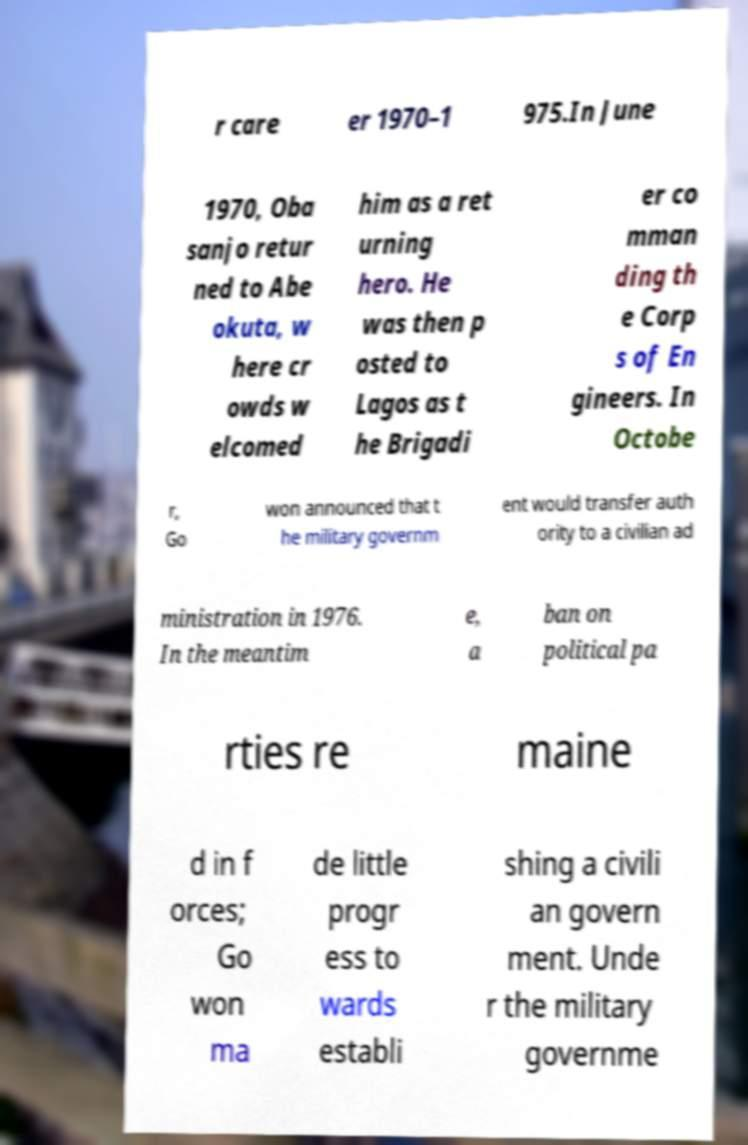Can you read and provide the text displayed in the image?This photo seems to have some interesting text. Can you extract and type it out for me? r care er 1970–1 975.In June 1970, Oba sanjo retur ned to Abe okuta, w here cr owds w elcomed him as a ret urning hero. He was then p osted to Lagos as t he Brigadi er co mman ding th e Corp s of En gineers. In Octobe r, Go won announced that t he military governm ent would transfer auth ority to a civilian ad ministration in 1976. In the meantim e, a ban on political pa rties re maine d in f orces; Go won ma de little progr ess to wards establi shing a civili an govern ment. Unde r the military governme 